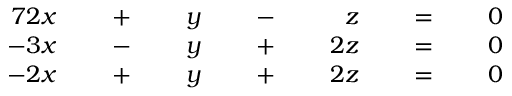Convert formula to latex. <formula><loc_0><loc_0><loc_500><loc_500>{ \begin{array} { r l r l r l r l r l r l r } { { 7 } 2 x } & { \, + \, } & { y } & { \, - \, } & { z } & { \, = \, } & { 0 } \\ { - 3 x } & { \, - \, } & { y } & { \, + \, } & { 2 z } & { \, = \, } & { 0 } \\ { - 2 x } & { \, + \, } & { y } & { \, + \, } & { 2 z } & { \, = \, } & { 0 } \end{array} }</formula> 